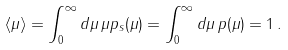Convert formula to latex. <formula><loc_0><loc_0><loc_500><loc_500>\langle \mu \rangle = \int _ { 0 } ^ { \infty } d \mu \, \mu p _ { s } ( \mu ) = \int _ { 0 } ^ { \infty } d \mu \, p ( \mu ) = 1 \, .</formula> 